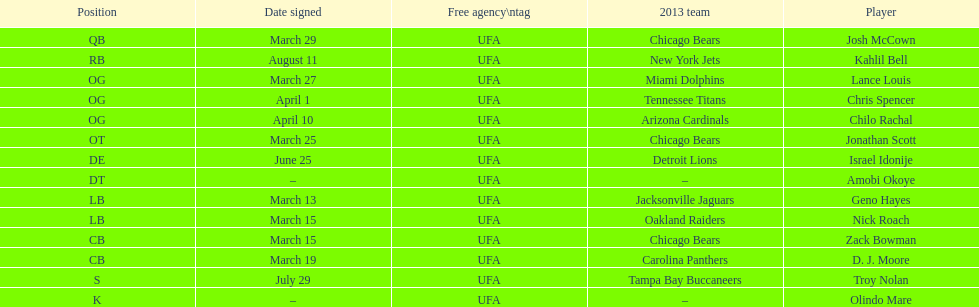How many free agents did this team pick up this season? 14. 